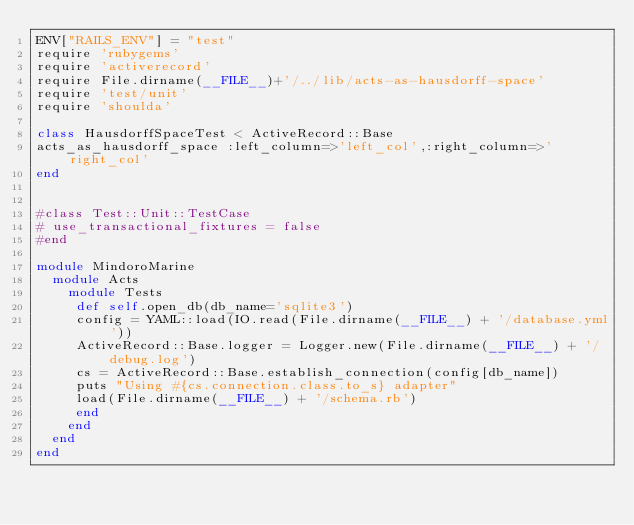<code> <loc_0><loc_0><loc_500><loc_500><_Ruby_>ENV["RAILS_ENV"] = "test"
require 'rubygems'
require 'activerecord'
require File.dirname(__FILE__)+'/../lib/acts-as-hausdorff-space'
require 'test/unit'
require 'shoulda'

class HausdorffSpaceTest < ActiveRecord::Base
acts_as_hausdorff_space :left_column=>'left_col',:right_column=>'right_col'
end


#class Test::Unit::TestCase
# use_transactional_fixtures = false
#end

module MindoroMarine
  module Acts
    module Tests
     def self.open_db(db_name='sqlite3')
     config = YAML::load(IO.read(File.dirname(__FILE__) + '/database.yml'))
     ActiveRecord::Base.logger = Logger.new(File.dirname(__FILE__) + '/debug.log')
     cs = ActiveRecord::Base.establish_connection(config[db_name])
     puts "Using #{cs.connection.class.to_s} adapter" 
     load(File.dirname(__FILE__) + '/schema.rb')
     end
    end
  end
end
</code> 